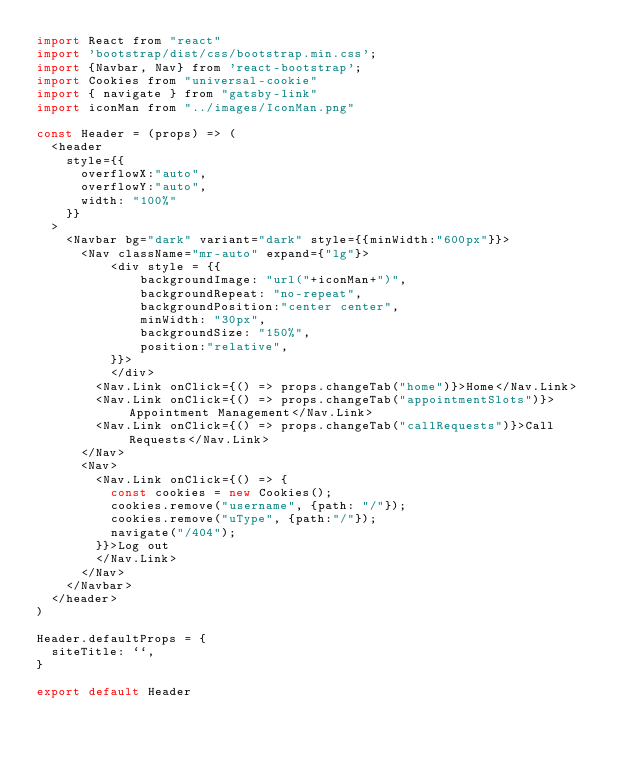<code> <loc_0><loc_0><loc_500><loc_500><_JavaScript_>import React from "react"
import 'bootstrap/dist/css/bootstrap.min.css';
import {Navbar, Nav} from 'react-bootstrap';
import Cookies from "universal-cookie"
import { navigate } from "gatsby-link"
import iconMan from "../images/IconMan.png"

const Header = (props) => (
  <header
    style={{
      overflowX:"auto",
      overflowY:"auto",
      width: "100%"
    }}
  >
    <Navbar bg="dark" variant="dark" style={{minWidth:"600px"}}>
      <Nav className="mr-auto" expand={"lg"}>
          <div style = {{
              backgroundImage: "url("+iconMan+")",
              backgroundRepeat: "no-repeat",
              backgroundPosition:"center center",
              minWidth: "30px",
              backgroundSize: "150%",
              position:"relative",
          }}>
          </div>
        <Nav.Link onClick={() => props.changeTab("home")}>Home</Nav.Link>
        <Nav.Link onClick={() => props.changeTab("appointmentSlots")}>Appointment Management</Nav.Link>
        <Nav.Link onClick={() => props.changeTab("callRequests")}>Call Requests</Nav.Link>
      </Nav>
      <Nav>
        <Nav.Link onClick={() => {
          const cookies = new Cookies();
          cookies.remove("username", {path: "/"});
          cookies.remove("uType", {path:"/"});
          navigate("/404");
        }}>Log out
        </Nav.Link>
      </Nav>
    </Navbar>
  </header>
)

Header.defaultProps = {
  siteTitle: ``,
}

export default Header
</code> 